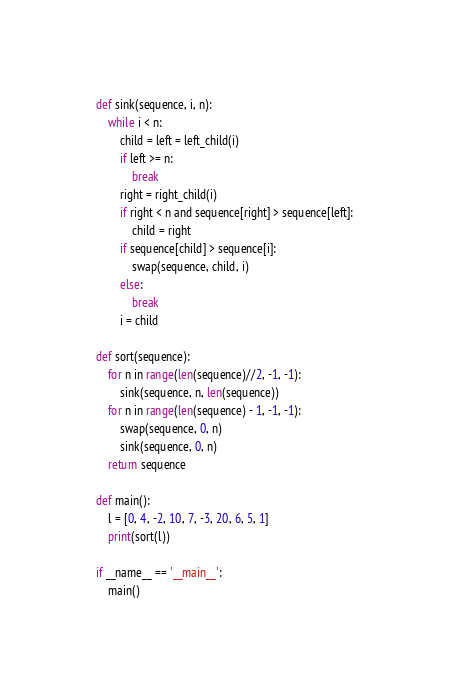<code> <loc_0><loc_0><loc_500><loc_500><_Python_>
def sink(sequence, i, n):
	while i < n:
		child = left = left_child(i)
		if left >= n:
			break
		right = right_child(i)
		if right < n and sequence[right] > sequence[left]:
			child = right
		if sequence[child] > sequence[i]:
			swap(sequence, child, i)
		else:
			break
		i = child

def sort(sequence):
	for n in range(len(sequence)//2, -1, -1):
		sink(sequence, n, len(sequence))
	for n in range(len(sequence) - 1, -1, -1):
		swap(sequence, 0, n)
		sink(sequence, 0, n)
	return sequence

def main():
	l = [0, 4, -2, 10, 7, -3, 20, 6, 5, 1]
	print(sort(l))

if __name__ == '__main__':
	main()</code> 